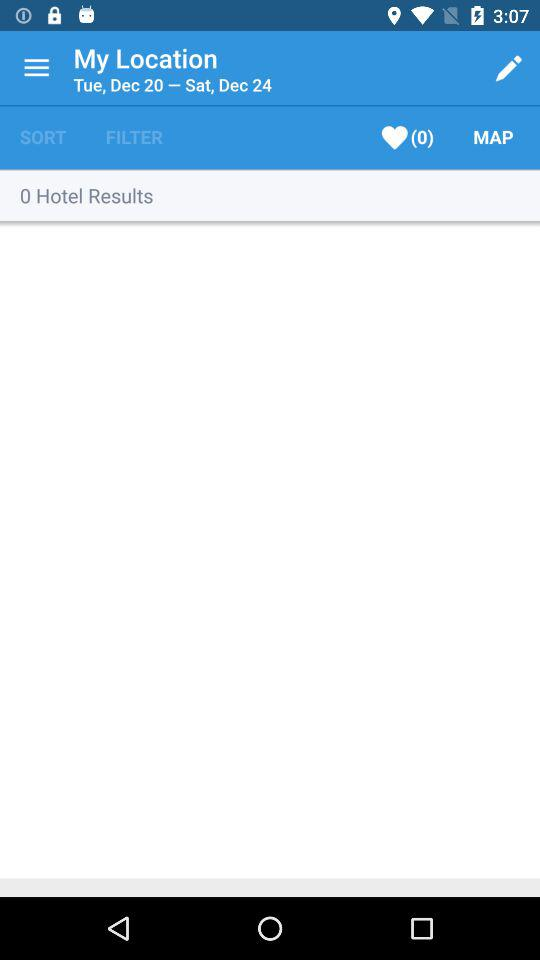What is the day on December 24? The day is Saturday. 